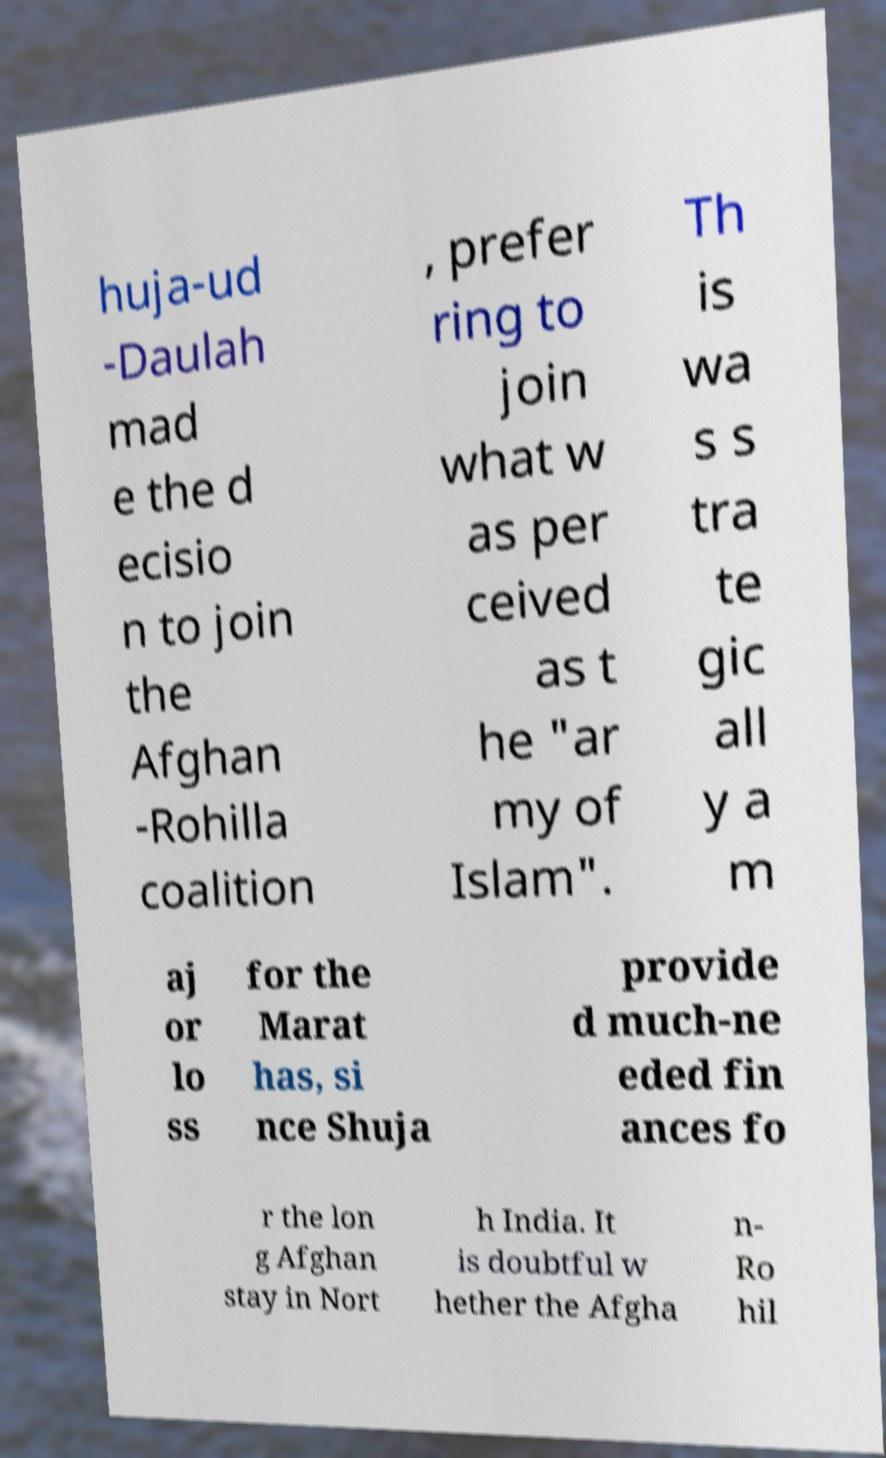I need the written content from this picture converted into text. Can you do that? huja-ud -Daulah mad e the d ecisio n to join the Afghan -Rohilla coalition , prefer ring to join what w as per ceived as t he "ar my of Islam". Th is wa s s tra te gic all y a m aj or lo ss for the Marat has, si nce Shuja provide d much-ne eded fin ances fo r the lon g Afghan stay in Nort h India. It is doubtful w hether the Afgha n- Ro hil 